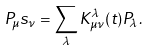<formula> <loc_0><loc_0><loc_500><loc_500>P _ { \mu } s _ { \nu } = \sum _ { \lambda } K ^ { \lambda } _ { \mu \nu } ( t ) P _ { \lambda } .</formula> 